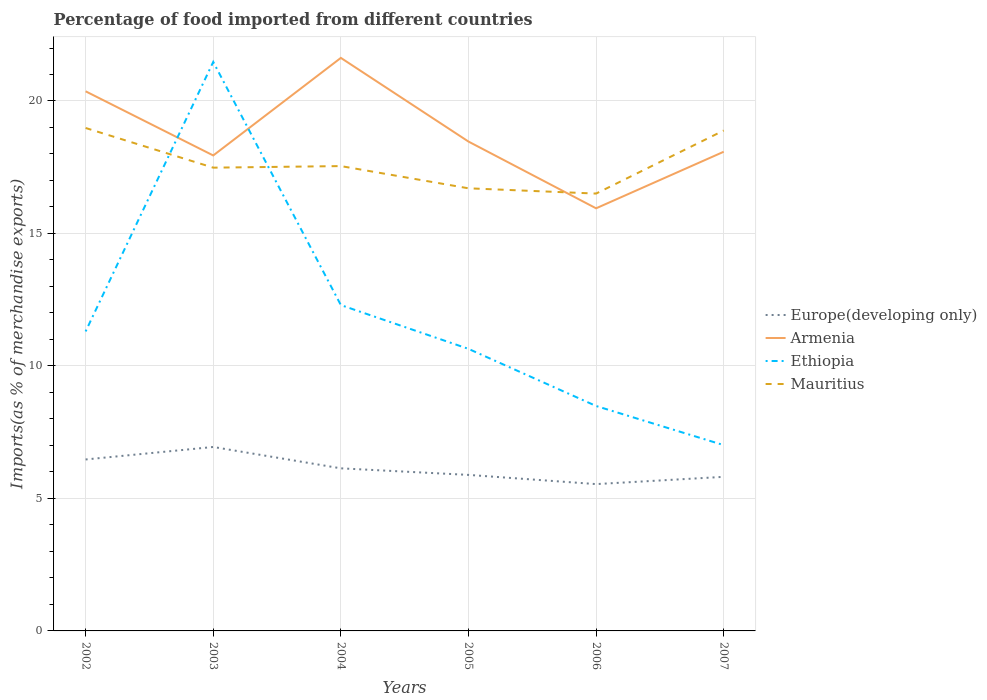Does the line corresponding to Armenia intersect with the line corresponding to Mauritius?
Keep it short and to the point. Yes. Is the number of lines equal to the number of legend labels?
Offer a terse response. Yes. Across all years, what is the maximum percentage of imports to different countries in Europe(developing only)?
Keep it short and to the point. 5.54. In which year was the percentage of imports to different countries in Europe(developing only) maximum?
Give a very brief answer. 2006. What is the total percentage of imports to different countries in Ethiopia in the graph?
Make the answer very short. 3.81. What is the difference between the highest and the second highest percentage of imports to different countries in Armenia?
Ensure brevity in your answer.  5.68. How many lines are there?
Offer a terse response. 4. What is the difference between two consecutive major ticks on the Y-axis?
Ensure brevity in your answer.  5. Are the values on the major ticks of Y-axis written in scientific E-notation?
Provide a short and direct response. No. Does the graph contain grids?
Offer a very short reply. Yes. How many legend labels are there?
Give a very brief answer. 4. How are the legend labels stacked?
Provide a short and direct response. Vertical. What is the title of the graph?
Keep it short and to the point. Percentage of food imported from different countries. What is the label or title of the Y-axis?
Offer a terse response. Imports(as % of merchandise exports). What is the Imports(as % of merchandise exports) in Europe(developing only) in 2002?
Make the answer very short. 6.47. What is the Imports(as % of merchandise exports) of Armenia in 2002?
Provide a short and direct response. 20.37. What is the Imports(as % of merchandise exports) in Ethiopia in 2002?
Keep it short and to the point. 11.3. What is the Imports(as % of merchandise exports) in Mauritius in 2002?
Your answer should be very brief. 18.98. What is the Imports(as % of merchandise exports) of Europe(developing only) in 2003?
Your answer should be compact. 6.94. What is the Imports(as % of merchandise exports) of Armenia in 2003?
Offer a terse response. 17.94. What is the Imports(as % of merchandise exports) in Ethiopia in 2003?
Make the answer very short. 21.47. What is the Imports(as % of merchandise exports) in Mauritius in 2003?
Make the answer very short. 17.48. What is the Imports(as % of merchandise exports) in Europe(developing only) in 2004?
Your answer should be compact. 6.14. What is the Imports(as % of merchandise exports) of Armenia in 2004?
Your response must be concise. 21.63. What is the Imports(as % of merchandise exports) in Ethiopia in 2004?
Provide a short and direct response. 12.3. What is the Imports(as % of merchandise exports) of Mauritius in 2004?
Ensure brevity in your answer.  17.54. What is the Imports(as % of merchandise exports) in Europe(developing only) in 2005?
Offer a terse response. 5.89. What is the Imports(as % of merchandise exports) of Armenia in 2005?
Offer a terse response. 18.47. What is the Imports(as % of merchandise exports) in Ethiopia in 2005?
Provide a succinct answer. 10.64. What is the Imports(as % of merchandise exports) of Mauritius in 2005?
Offer a terse response. 16.7. What is the Imports(as % of merchandise exports) of Europe(developing only) in 2006?
Offer a terse response. 5.54. What is the Imports(as % of merchandise exports) in Armenia in 2006?
Offer a very short reply. 15.95. What is the Imports(as % of merchandise exports) in Ethiopia in 2006?
Your response must be concise. 8.49. What is the Imports(as % of merchandise exports) in Mauritius in 2006?
Provide a succinct answer. 16.51. What is the Imports(as % of merchandise exports) of Europe(developing only) in 2007?
Keep it short and to the point. 5.82. What is the Imports(as % of merchandise exports) in Armenia in 2007?
Make the answer very short. 18.08. What is the Imports(as % of merchandise exports) of Ethiopia in 2007?
Ensure brevity in your answer.  7.01. What is the Imports(as % of merchandise exports) in Mauritius in 2007?
Your response must be concise. 18.89. Across all years, what is the maximum Imports(as % of merchandise exports) of Europe(developing only)?
Your answer should be very brief. 6.94. Across all years, what is the maximum Imports(as % of merchandise exports) of Armenia?
Your response must be concise. 21.63. Across all years, what is the maximum Imports(as % of merchandise exports) in Ethiopia?
Keep it short and to the point. 21.47. Across all years, what is the maximum Imports(as % of merchandise exports) of Mauritius?
Provide a short and direct response. 18.98. Across all years, what is the minimum Imports(as % of merchandise exports) in Europe(developing only)?
Offer a terse response. 5.54. Across all years, what is the minimum Imports(as % of merchandise exports) in Armenia?
Your answer should be compact. 15.95. Across all years, what is the minimum Imports(as % of merchandise exports) of Ethiopia?
Give a very brief answer. 7.01. Across all years, what is the minimum Imports(as % of merchandise exports) in Mauritius?
Give a very brief answer. 16.51. What is the total Imports(as % of merchandise exports) in Europe(developing only) in the graph?
Ensure brevity in your answer.  36.79. What is the total Imports(as % of merchandise exports) in Armenia in the graph?
Provide a short and direct response. 112.44. What is the total Imports(as % of merchandise exports) of Ethiopia in the graph?
Provide a succinct answer. 71.22. What is the total Imports(as % of merchandise exports) in Mauritius in the graph?
Your response must be concise. 106.11. What is the difference between the Imports(as % of merchandise exports) of Europe(developing only) in 2002 and that in 2003?
Offer a terse response. -0.47. What is the difference between the Imports(as % of merchandise exports) of Armenia in 2002 and that in 2003?
Your answer should be very brief. 2.42. What is the difference between the Imports(as % of merchandise exports) in Ethiopia in 2002 and that in 2003?
Keep it short and to the point. -10.17. What is the difference between the Imports(as % of merchandise exports) in Mauritius in 2002 and that in 2003?
Ensure brevity in your answer.  1.5. What is the difference between the Imports(as % of merchandise exports) of Europe(developing only) in 2002 and that in 2004?
Your answer should be compact. 0.33. What is the difference between the Imports(as % of merchandise exports) in Armenia in 2002 and that in 2004?
Provide a short and direct response. -1.26. What is the difference between the Imports(as % of merchandise exports) of Ethiopia in 2002 and that in 2004?
Keep it short and to the point. -0.99. What is the difference between the Imports(as % of merchandise exports) in Mauritius in 2002 and that in 2004?
Give a very brief answer. 1.44. What is the difference between the Imports(as % of merchandise exports) in Europe(developing only) in 2002 and that in 2005?
Ensure brevity in your answer.  0.58. What is the difference between the Imports(as % of merchandise exports) of Armenia in 2002 and that in 2005?
Provide a short and direct response. 1.9. What is the difference between the Imports(as % of merchandise exports) in Ethiopia in 2002 and that in 2005?
Your response must be concise. 0.66. What is the difference between the Imports(as % of merchandise exports) in Mauritius in 2002 and that in 2005?
Your answer should be compact. 2.28. What is the difference between the Imports(as % of merchandise exports) of Europe(developing only) in 2002 and that in 2006?
Your response must be concise. 0.93. What is the difference between the Imports(as % of merchandise exports) in Armenia in 2002 and that in 2006?
Ensure brevity in your answer.  4.42. What is the difference between the Imports(as % of merchandise exports) of Ethiopia in 2002 and that in 2006?
Provide a succinct answer. 2.81. What is the difference between the Imports(as % of merchandise exports) in Mauritius in 2002 and that in 2006?
Offer a very short reply. 2.48. What is the difference between the Imports(as % of merchandise exports) in Europe(developing only) in 2002 and that in 2007?
Offer a very short reply. 0.66. What is the difference between the Imports(as % of merchandise exports) in Armenia in 2002 and that in 2007?
Give a very brief answer. 2.28. What is the difference between the Imports(as % of merchandise exports) in Ethiopia in 2002 and that in 2007?
Provide a short and direct response. 4.29. What is the difference between the Imports(as % of merchandise exports) in Mauritius in 2002 and that in 2007?
Your answer should be very brief. 0.09. What is the difference between the Imports(as % of merchandise exports) in Europe(developing only) in 2003 and that in 2004?
Your answer should be compact. 0.81. What is the difference between the Imports(as % of merchandise exports) in Armenia in 2003 and that in 2004?
Offer a terse response. -3.68. What is the difference between the Imports(as % of merchandise exports) in Ethiopia in 2003 and that in 2004?
Make the answer very short. 9.18. What is the difference between the Imports(as % of merchandise exports) of Mauritius in 2003 and that in 2004?
Keep it short and to the point. -0.06. What is the difference between the Imports(as % of merchandise exports) in Europe(developing only) in 2003 and that in 2005?
Provide a succinct answer. 1.05. What is the difference between the Imports(as % of merchandise exports) in Armenia in 2003 and that in 2005?
Ensure brevity in your answer.  -0.52. What is the difference between the Imports(as % of merchandise exports) of Ethiopia in 2003 and that in 2005?
Your response must be concise. 10.83. What is the difference between the Imports(as % of merchandise exports) of Mauritius in 2003 and that in 2005?
Your answer should be very brief. 0.78. What is the difference between the Imports(as % of merchandise exports) in Europe(developing only) in 2003 and that in 2006?
Your answer should be compact. 1.4. What is the difference between the Imports(as % of merchandise exports) of Armenia in 2003 and that in 2006?
Your answer should be compact. 1.99. What is the difference between the Imports(as % of merchandise exports) in Ethiopia in 2003 and that in 2006?
Keep it short and to the point. 12.99. What is the difference between the Imports(as % of merchandise exports) of Mauritius in 2003 and that in 2006?
Provide a short and direct response. 0.98. What is the difference between the Imports(as % of merchandise exports) of Europe(developing only) in 2003 and that in 2007?
Provide a short and direct response. 1.13. What is the difference between the Imports(as % of merchandise exports) in Armenia in 2003 and that in 2007?
Make the answer very short. -0.14. What is the difference between the Imports(as % of merchandise exports) of Ethiopia in 2003 and that in 2007?
Your response must be concise. 14.46. What is the difference between the Imports(as % of merchandise exports) in Mauritius in 2003 and that in 2007?
Offer a terse response. -1.4. What is the difference between the Imports(as % of merchandise exports) in Europe(developing only) in 2004 and that in 2005?
Your answer should be very brief. 0.25. What is the difference between the Imports(as % of merchandise exports) in Armenia in 2004 and that in 2005?
Provide a short and direct response. 3.16. What is the difference between the Imports(as % of merchandise exports) in Ethiopia in 2004 and that in 2005?
Your answer should be compact. 1.65. What is the difference between the Imports(as % of merchandise exports) in Mauritius in 2004 and that in 2005?
Offer a terse response. 0.84. What is the difference between the Imports(as % of merchandise exports) of Europe(developing only) in 2004 and that in 2006?
Give a very brief answer. 0.6. What is the difference between the Imports(as % of merchandise exports) of Armenia in 2004 and that in 2006?
Give a very brief answer. 5.68. What is the difference between the Imports(as % of merchandise exports) in Ethiopia in 2004 and that in 2006?
Make the answer very short. 3.81. What is the difference between the Imports(as % of merchandise exports) of Mauritius in 2004 and that in 2006?
Make the answer very short. 1.04. What is the difference between the Imports(as % of merchandise exports) in Europe(developing only) in 2004 and that in 2007?
Keep it short and to the point. 0.32. What is the difference between the Imports(as % of merchandise exports) of Armenia in 2004 and that in 2007?
Your answer should be compact. 3.54. What is the difference between the Imports(as % of merchandise exports) of Ethiopia in 2004 and that in 2007?
Your answer should be compact. 5.28. What is the difference between the Imports(as % of merchandise exports) of Mauritius in 2004 and that in 2007?
Offer a very short reply. -1.34. What is the difference between the Imports(as % of merchandise exports) of Europe(developing only) in 2005 and that in 2006?
Keep it short and to the point. 0.35. What is the difference between the Imports(as % of merchandise exports) of Armenia in 2005 and that in 2006?
Your response must be concise. 2.52. What is the difference between the Imports(as % of merchandise exports) in Ethiopia in 2005 and that in 2006?
Provide a succinct answer. 2.16. What is the difference between the Imports(as % of merchandise exports) of Mauritius in 2005 and that in 2006?
Offer a terse response. 0.2. What is the difference between the Imports(as % of merchandise exports) of Europe(developing only) in 2005 and that in 2007?
Make the answer very short. 0.07. What is the difference between the Imports(as % of merchandise exports) in Armenia in 2005 and that in 2007?
Provide a short and direct response. 0.38. What is the difference between the Imports(as % of merchandise exports) in Ethiopia in 2005 and that in 2007?
Keep it short and to the point. 3.63. What is the difference between the Imports(as % of merchandise exports) of Mauritius in 2005 and that in 2007?
Ensure brevity in your answer.  -2.18. What is the difference between the Imports(as % of merchandise exports) of Europe(developing only) in 2006 and that in 2007?
Offer a very short reply. -0.27. What is the difference between the Imports(as % of merchandise exports) of Armenia in 2006 and that in 2007?
Make the answer very short. -2.13. What is the difference between the Imports(as % of merchandise exports) in Ethiopia in 2006 and that in 2007?
Provide a succinct answer. 1.48. What is the difference between the Imports(as % of merchandise exports) of Mauritius in 2006 and that in 2007?
Provide a succinct answer. -2.38. What is the difference between the Imports(as % of merchandise exports) in Europe(developing only) in 2002 and the Imports(as % of merchandise exports) in Armenia in 2003?
Your response must be concise. -11.47. What is the difference between the Imports(as % of merchandise exports) in Europe(developing only) in 2002 and the Imports(as % of merchandise exports) in Ethiopia in 2003?
Your response must be concise. -15. What is the difference between the Imports(as % of merchandise exports) of Europe(developing only) in 2002 and the Imports(as % of merchandise exports) of Mauritius in 2003?
Ensure brevity in your answer.  -11.01. What is the difference between the Imports(as % of merchandise exports) in Armenia in 2002 and the Imports(as % of merchandise exports) in Ethiopia in 2003?
Provide a succinct answer. -1.11. What is the difference between the Imports(as % of merchandise exports) of Armenia in 2002 and the Imports(as % of merchandise exports) of Mauritius in 2003?
Offer a terse response. 2.88. What is the difference between the Imports(as % of merchandise exports) of Ethiopia in 2002 and the Imports(as % of merchandise exports) of Mauritius in 2003?
Your answer should be very brief. -6.18. What is the difference between the Imports(as % of merchandise exports) of Europe(developing only) in 2002 and the Imports(as % of merchandise exports) of Armenia in 2004?
Provide a succinct answer. -15.16. What is the difference between the Imports(as % of merchandise exports) of Europe(developing only) in 2002 and the Imports(as % of merchandise exports) of Ethiopia in 2004?
Provide a succinct answer. -5.83. What is the difference between the Imports(as % of merchandise exports) in Europe(developing only) in 2002 and the Imports(as % of merchandise exports) in Mauritius in 2004?
Your response must be concise. -11.07. What is the difference between the Imports(as % of merchandise exports) in Armenia in 2002 and the Imports(as % of merchandise exports) in Ethiopia in 2004?
Make the answer very short. 8.07. What is the difference between the Imports(as % of merchandise exports) in Armenia in 2002 and the Imports(as % of merchandise exports) in Mauritius in 2004?
Give a very brief answer. 2.82. What is the difference between the Imports(as % of merchandise exports) in Ethiopia in 2002 and the Imports(as % of merchandise exports) in Mauritius in 2004?
Ensure brevity in your answer.  -6.24. What is the difference between the Imports(as % of merchandise exports) of Europe(developing only) in 2002 and the Imports(as % of merchandise exports) of Armenia in 2005?
Your answer should be compact. -12. What is the difference between the Imports(as % of merchandise exports) of Europe(developing only) in 2002 and the Imports(as % of merchandise exports) of Ethiopia in 2005?
Your answer should be compact. -4.17. What is the difference between the Imports(as % of merchandise exports) in Europe(developing only) in 2002 and the Imports(as % of merchandise exports) in Mauritius in 2005?
Your response must be concise. -10.23. What is the difference between the Imports(as % of merchandise exports) in Armenia in 2002 and the Imports(as % of merchandise exports) in Ethiopia in 2005?
Ensure brevity in your answer.  9.72. What is the difference between the Imports(as % of merchandise exports) of Armenia in 2002 and the Imports(as % of merchandise exports) of Mauritius in 2005?
Provide a succinct answer. 3.66. What is the difference between the Imports(as % of merchandise exports) in Ethiopia in 2002 and the Imports(as % of merchandise exports) in Mauritius in 2005?
Make the answer very short. -5.4. What is the difference between the Imports(as % of merchandise exports) of Europe(developing only) in 2002 and the Imports(as % of merchandise exports) of Armenia in 2006?
Your answer should be very brief. -9.48. What is the difference between the Imports(as % of merchandise exports) of Europe(developing only) in 2002 and the Imports(as % of merchandise exports) of Ethiopia in 2006?
Your answer should be compact. -2.02. What is the difference between the Imports(as % of merchandise exports) in Europe(developing only) in 2002 and the Imports(as % of merchandise exports) in Mauritius in 2006?
Provide a short and direct response. -10.04. What is the difference between the Imports(as % of merchandise exports) in Armenia in 2002 and the Imports(as % of merchandise exports) in Ethiopia in 2006?
Your answer should be compact. 11.88. What is the difference between the Imports(as % of merchandise exports) of Armenia in 2002 and the Imports(as % of merchandise exports) of Mauritius in 2006?
Ensure brevity in your answer.  3.86. What is the difference between the Imports(as % of merchandise exports) of Ethiopia in 2002 and the Imports(as % of merchandise exports) of Mauritius in 2006?
Offer a terse response. -5.2. What is the difference between the Imports(as % of merchandise exports) in Europe(developing only) in 2002 and the Imports(as % of merchandise exports) in Armenia in 2007?
Your response must be concise. -11.61. What is the difference between the Imports(as % of merchandise exports) in Europe(developing only) in 2002 and the Imports(as % of merchandise exports) in Ethiopia in 2007?
Keep it short and to the point. -0.54. What is the difference between the Imports(as % of merchandise exports) of Europe(developing only) in 2002 and the Imports(as % of merchandise exports) of Mauritius in 2007?
Your response must be concise. -12.42. What is the difference between the Imports(as % of merchandise exports) of Armenia in 2002 and the Imports(as % of merchandise exports) of Ethiopia in 2007?
Make the answer very short. 13.35. What is the difference between the Imports(as % of merchandise exports) of Armenia in 2002 and the Imports(as % of merchandise exports) of Mauritius in 2007?
Give a very brief answer. 1.48. What is the difference between the Imports(as % of merchandise exports) in Ethiopia in 2002 and the Imports(as % of merchandise exports) in Mauritius in 2007?
Give a very brief answer. -7.58. What is the difference between the Imports(as % of merchandise exports) of Europe(developing only) in 2003 and the Imports(as % of merchandise exports) of Armenia in 2004?
Make the answer very short. -14.68. What is the difference between the Imports(as % of merchandise exports) in Europe(developing only) in 2003 and the Imports(as % of merchandise exports) in Ethiopia in 2004?
Your answer should be compact. -5.36. What is the difference between the Imports(as % of merchandise exports) of Europe(developing only) in 2003 and the Imports(as % of merchandise exports) of Mauritius in 2004?
Give a very brief answer. -10.6. What is the difference between the Imports(as % of merchandise exports) in Armenia in 2003 and the Imports(as % of merchandise exports) in Ethiopia in 2004?
Your answer should be compact. 5.65. What is the difference between the Imports(as % of merchandise exports) in Armenia in 2003 and the Imports(as % of merchandise exports) in Mauritius in 2004?
Keep it short and to the point. 0.4. What is the difference between the Imports(as % of merchandise exports) in Ethiopia in 2003 and the Imports(as % of merchandise exports) in Mauritius in 2004?
Give a very brief answer. 3.93. What is the difference between the Imports(as % of merchandise exports) in Europe(developing only) in 2003 and the Imports(as % of merchandise exports) in Armenia in 2005?
Your answer should be very brief. -11.53. What is the difference between the Imports(as % of merchandise exports) of Europe(developing only) in 2003 and the Imports(as % of merchandise exports) of Ethiopia in 2005?
Provide a short and direct response. -3.7. What is the difference between the Imports(as % of merchandise exports) of Europe(developing only) in 2003 and the Imports(as % of merchandise exports) of Mauritius in 2005?
Keep it short and to the point. -9.76. What is the difference between the Imports(as % of merchandise exports) in Armenia in 2003 and the Imports(as % of merchandise exports) in Ethiopia in 2005?
Give a very brief answer. 7.3. What is the difference between the Imports(as % of merchandise exports) in Armenia in 2003 and the Imports(as % of merchandise exports) in Mauritius in 2005?
Give a very brief answer. 1.24. What is the difference between the Imports(as % of merchandise exports) of Ethiopia in 2003 and the Imports(as % of merchandise exports) of Mauritius in 2005?
Keep it short and to the point. 4.77. What is the difference between the Imports(as % of merchandise exports) in Europe(developing only) in 2003 and the Imports(as % of merchandise exports) in Armenia in 2006?
Offer a very short reply. -9.01. What is the difference between the Imports(as % of merchandise exports) of Europe(developing only) in 2003 and the Imports(as % of merchandise exports) of Ethiopia in 2006?
Give a very brief answer. -1.55. What is the difference between the Imports(as % of merchandise exports) of Europe(developing only) in 2003 and the Imports(as % of merchandise exports) of Mauritius in 2006?
Ensure brevity in your answer.  -9.56. What is the difference between the Imports(as % of merchandise exports) in Armenia in 2003 and the Imports(as % of merchandise exports) in Ethiopia in 2006?
Give a very brief answer. 9.46. What is the difference between the Imports(as % of merchandise exports) in Armenia in 2003 and the Imports(as % of merchandise exports) in Mauritius in 2006?
Your answer should be compact. 1.44. What is the difference between the Imports(as % of merchandise exports) in Ethiopia in 2003 and the Imports(as % of merchandise exports) in Mauritius in 2006?
Offer a terse response. 4.97. What is the difference between the Imports(as % of merchandise exports) of Europe(developing only) in 2003 and the Imports(as % of merchandise exports) of Armenia in 2007?
Keep it short and to the point. -11.14. What is the difference between the Imports(as % of merchandise exports) of Europe(developing only) in 2003 and the Imports(as % of merchandise exports) of Ethiopia in 2007?
Your answer should be compact. -0.07. What is the difference between the Imports(as % of merchandise exports) in Europe(developing only) in 2003 and the Imports(as % of merchandise exports) in Mauritius in 2007?
Your answer should be very brief. -11.94. What is the difference between the Imports(as % of merchandise exports) of Armenia in 2003 and the Imports(as % of merchandise exports) of Ethiopia in 2007?
Make the answer very short. 10.93. What is the difference between the Imports(as % of merchandise exports) of Armenia in 2003 and the Imports(as % of merchandise exports) of Mauritius in 2007?
Offer a terse response. -0.94. What is the difference between the Imports(as % of merchandise exports) of Ethiopia in 2003 and the Imports(as % of merchandise exports) of Mauritius in 2007?
Offer a very short reply. 2.59. What is the difference between the Imports(as % of merchandise exports) of Europe(developing only) in 2004 and the Imports(as % of merchandise exports) of Armenia in 2005?
Provide a short and direct response. -12.33. What is the difference between the Imports(as % of merchandise exports) of Europe(developing only) in 2004 and the Imports(as % of merchandise exports) of Ethiopia in 2005?
Ensure brevity in your answer.  -4.51. What is the difference between the Imports(as % of merchandise exports) in Europe(developing only) in 2004 and the Imports(as % of merchandise exports) in Mauritius in 2005?
Ensure brevity in your answer.  -10.57. What is the difference between the Imports(as % of merchandise exports) of Armenia in 2004 and the Imports(as % of merchandise exports) of Ethiopia in 2005?
Keep it short and to the point. 10.98. What is the difference between the Imports(as % of merchandise exports) of Armenia in 2004 and the Imports(as % of merchandise exports) of Mauritius in 2005?
Ensure brevity in your answer.  4.92. What is the difference between the Imports(as % of merchandise exports) in Ethiopia in 2004 and the Imports(as % of merchandise exports) in Mauritius in 2005?
Provide a succinct answer. -4.41. What is the difference between the Imports(as % of merchandise exports) in Europe(developing only) in 2004 and the Imports(as % of merchandise exports) in Armenia in 2006?
Your response must be concise. -9.81. What is the difference between the Imports(as % of merchandise exports) in Europe(developing only) in 2004 and the Imports(as % of merchandise exports) in Ethiopia in 2006?
Keep it short and to the point. -2.35. What is the difference between the Imports(as % of merchandise exports) of Europe(developing only) in 2004 and the Imports(as % of merchandise exports) of Mauritius in 2006?
Make the answer very short. -10.37. What is the difference between the Imports(as % of merchandise exports) in Armenia in 2004 and the Imports(as % of merchandise exports) in Ethiopia in 2006?
Offer a very short reply. 13.14. What is the difference between the Imports(as % of merchandise exports) in Armenia in 2004 and the Imports(as % of merchandise exports) in Mauritius in 2006?
Ensure brevity in your answer.  5.12. What is the difference between the Imports(as % of merchandise exports) in Ethiopia in 2004 and the Imports(as % of merchandise exports) in Mauritius in 2006?
Your answer should be compact. -4.21. What is the difference between the Imports(as % of merchandise exports) in Europe(developing only) in 2004 and the Imports(as % of merchandise exports) in Armenia in 2007?
Keep it short and to the point. -11.95. What is the difference between the Imports(as % of merchandise exports) in Europe(developing only) in 2004 and the Imports(as % of merchandise exports) in Ethiopia in 2007?
Your answer should be compact. -0.88. What is the difference between the Imports(as % of merchandise exports) of Europe(developing only) in 2004 and the Imports(as % of merchandise exports) of Mauritius in 2007?
Give a very brief answer. -12.75. What is the difference between the Imports(as % of merchandise exports) in Armenia in 2004 and the Imports(as % of merchandise exports) in Ethiopia in 2007?
Offer a very short reply. 14.61. What is the difference between the Imports(as % of merchandise exports) in Armenia in 2004 and the Imports(as % of merchandise exports) in Mauritius in 2007?
Ensure brevity in your answer.  2.74. What is the difference between the Imports(as % of merchandise exports) in Ethiopia in 2004 and the Imports(as % of merchandise exports) in Mauritius in 2007?
Offer a very short reply. -6.59. What is the difference between the Imports(as % of merchandise exports) of Europe(developing only) in 2005 and the Imports(as % of merchandise exports) of Armenia in 2006?
Make the answer very short. -10.06. What is the difference between the Imports(as % of merchandise exports) of Europe(developing only) in 2005 and the Imports(as % of merchandise exports) of Ethiopia in 2006?
Keep it short and to the point. -2.6. What is the difference between the Imports(as % of merchandise exports) of Europe(developing only) in 2005 and the Imports(as % of merchandise exports) of Mauritius in 2006?
Make the answer very short. -10.62. What is the difference between the Imports(as % of merchandise exports) in Armenia in 2005 and the Imports(as % of merchandise exports) in Ethiopia in 2006?
Your response must be concise. 9.98. What is the difference between the Imports(as % of merchandise exports) in Armenia in 2005 and the Imports(as % of merchandise exports) in Mauritius in 2006?
Give a very brief answer. 1.96. What is the difference between the Imports(as % of merchandise exports) in Ethiopia in 2005 and the Imports(as % of merchandise exports) in Mauritius in 2006?
Keep it short and to the point. -5.86. What is the difference between the Imports(as % of merchandise exports) in Europe(developing only) in 2005 and the Imports(as % of merchandise exports) in Armenia in 2007?
Ensure brevity in your answer.  -12.2. What is the difference between the Imports(as % of merchandise exports) in Europe(developing only) in 2005 and the Imports(as % of merchandise exports) in Ethiopia in 2007?
Ensure brevity in your answer.  -1.12. What is the difference between the Imports(as % of merchandise exports) in Europe(developing only) in 2005 and the Imports(as % of merchandise exports) in Mauritius in 2007?
Provide a succinct answer. -13. What is the difference between the Imports(as % of merchandise exports) in Armenia in 2005 and the Imports(as % of merchandise exports) in Ethiopia in 2007?
Your answer should be compact. 11.46. What is the difference between the Imports(as % of merchandise exports) of Armenia in 2005 and the Imports(as % of merchandise exports) of Mauritius in 2007?
Make the answer very short. -0.42. What is the difference between the Imports(as % of merchandise exports) of Ethiopia in 2005 and the Imports(as % of merchandise exports) of Mauritius in 2007?
Your answer should be compact. -8.24. What is the difference between the Imports(as % of merchandise exports) in Europe(developing only) in 2006 and the Imports(as % of merchandise exports) in Armenia in 2007?
Offer a terse response. -12.54. What is the difference between the Imports(as % of merchandise exports) in Europe(developing only) in 2006 and the Imports(as % of merchandise exports) in Ethiopia in 2007?
Offer a terse response. -1.47. What is the difference between the Imports(as % of merchandise exports) in Europe(developing only) in 2006 and the Imports(as % of merchandise exports) in Mauritius in 2007?
Your answer should be very brief. -13.35. What is the difference between the Imports(as % of merchandise exports) of Armenia in 2006 and the Imports(as % of merchandise exports) of Ethiopia in 2007?
Ensure brevity in your answer.  8.94. What is the difference between the Imports(as % of merchandise exports) in Armenia in 2006 and the Imports(as % of merchandise exports) in Mauritius in 2007?
Your response must be concise. -2.94. What is the difference between the Imports(as % of merchandise exports) in Ethiopia in 2006 and the Imports(as % of merchandise exports) in Mauritius in 2007?
Your answer should be compact. -10.4. What is the average Imports(as % of merchandise exports) in Europe(developing only) per year?
Provide a short and direct response. 6.13. What is the average Imports(as % of merchandise exports) of Armenia per year?
Ensure brevity in your answer.  18.74. What is the average Imports(as % of merchandise exports) in Ethiopia per year?
Your answer should be very brief. 11.87. What is the average Imports(as % of merchandise exports) of Mauritius per year?
Offer a terse response. 17.68. In the year 2002, what is the difference between the Imports(as % of merchandise exports) of Europe(developing only) and Imports(as % of merchandise exports) of Armenia?
Your answer should be compact. -13.89. In the year 2002, what is the difference between the Imports(as % of merchandise exports) in Europe(developing only) and Imports(as % of merchandise exports) in Ethiopia?
Your response must be concise. -4.83. In the year 2002, what is the difference between the Imports(as % of merchandise exports) of Europe(developing only) and Imports(as % of merchandise exports) of Mauritius?
Offer a terse response. -12.51. In the year 2002, what is the difference between the Imports(as % of merchandise exports) of Armenia and Imports(as % of merchandise exports) of Ethiopia?
Your answer should be very brief. 9.06. In the year 2002, what is the difference between the Imports(as % of merchandise exports) in Armenia and Imports(as % of merchandise exports) in Mauritius?
Your response must be concise. 1.38. In the year 2002, what is the difference between the Imports(as % of merchandise exports) in Ethiopia and Imports(as % of merchandise exports) in Mauritius?
Offer a very short reply. -7.68. In the year 2003, what is the difference between the Imports(as % of merchandise exports) in Europe(developing only) and Imports(as % of merchandise exports) in Armenia?
Provide a short and direct response. -11. In the year 2003, what is the difference between the Imports(as % of merchandise exports) of Europe(developing only) and Imports(as % of merchandise exports) of Ethiopia?
Your answer should be very brief. -14.53. In the year 2003, what is the difference between the Imports(as % of merchandise exports) of Europe(developing only) and Imports(as % of merchandise exports) of Mauritius?
Your answer should be compact. -10.54. In the year 2003, what is the difference between the Imports(as % of merchandise exports) of Armenia and Imports(as % of merchandise exports) of Ethiopia?
Your answer should be very brief. -3.53. In the year 2003, what is the difference between the Imports(as % of merchandise exports) of Armenia and Imports(as % of merchandise exports) of Mauritius?
Make the answer very short. 0.46. In the year 2003, what is the difference between the Imports(as % of merchandise exports) in Ethiopia and Imports(as % of merchandise exports) in Mauritius?
Give a very brief answer. 3.99. In the year 2004, what is the difference between the Imports(as % of merchandise exports) in Europe(developing only) and Imports(as % of merchandise exports) in Armenia?
Your response must be concise. -15.49. In the year 2004, what is the difference between the Imports(as % of merchandise exports) in Europe(developing only) and Imports(as % of merchandise exports) in Ethiopia?
Your answer should be very brief. -6.16. In the year 2004, what is the difference between the Imports(as % of merchandise exports) of Europe(developing only) and Imports(as % of merchandise exports) of Mauritius?
Offer a terse response. -11.41. In the year 2004, what is the difference between the Imports(as % of merchandise exports) in Armenia and Imports(as % of merchandise exports) in Ethiopia?
Keep it short and to the point. 9.33. In the year 2004, what is the difference between the Imports(as % of merchandise exports) of Armenia and Imports(as % of merchandise exports) of Mauritius?
Provide a succinct answer. 4.08. In the year 2004, what is the difference between the Imports(as % of merchandise exports) in Ethiopia and Imports(as % of merchandise exports) in Mauritius?
Provide a succinct answer. -5.25. In the year 2005, what is the difference between the Imports(as % of merchandise exports) of Europe(developing only) and Imports(as % of merchandise exports) of Armenia?
Ensure brevity in your answer.  -12.58. In the year 2005, what is the difference between the Imports(as % of merchandise exports) of Europe(developing only) and Imports(as % of merchandise exports) of Ethiopia?
Give a very brief answer. -4.76. In the year 2005, what is the difference between the Imports(as % of merchandise exports) in Europe(developing only) and Imports(as % of merchandise exports) in Mauritius?
Ensure brevity in your answer.  -10.82. In the year 2005, what is the difference between the Imports(as % of merchandise exports) of Armenia and Imports(as % of merchandise exports) of Ethiopia?
Your answer should be very brief. 7.82. In the year 2005, what is the difference between the Imports(as % of merchandise exports) in Armenia and Imports(as % of merchandise exports) in Mauritius?
Offer a very short reply. 1.76. In the year 2005, what is the difference between the Imports(as % of merchandise exports) of Ethiopia and Imports(as % of merchandise exports) of Mauritius?
Your response must be concise. -6.06. In the year 2006, what is the difference between the Imports(as % of merchandise exports) in Europe(developing only) and Imports(as % of merchandise exports) in Armenia?
Ensure brevity in your answer.  -10.41. In the year 2006, what is the difference between the Imports(as % of merchandise exports) of Europe(developing only) and Imports(as % of merchandise exports) of Ethiopia?
Your answer should be compact. -2.95. In the year 2006, what is the difference between the Imports(as % of merchandise exports) in Europe(developing only) and Imports(as % of merchandise exports) in Mauritius?
Provide a short and direct response. -10.96. In the year 2006, what is the difference between the Imports(as % of merchandise exports) in Armenia and Imports(as % of merchandise exports) in Ethiopia?
Your answer should be very brief. 7.46. In the year 2006, what is the difference between the Imports(as % of merchandise exports) of Armenia and Imports(as % of merchandise exports) of Mauritius?
Provide a succinct answer. -0.56. In the year 2006, what is the difference between the Imports(as % of merchandise exports) of Ethiopia and Imports(as % of merchandise exports) of Mauritius?
Your answer should be very brief. -8.02. In the year 2007, what is the difference between the Imports(as % of merchandise exports) in Europe(developing only) and Imports(as % of merchandise exports) in Armenia?
Keep it short and to the point. -12.27. In the year 2007, what is the difference between the Imports(as % of merchandise exports) in Europe(developing only) and Imports(as % of merchandise exports) in Ethiopia?
Give a very brief answer. -1.2. In the year 2007, what is the difference between the Imports(as % of merchandise exports) in Europe(developing only) and Imports(as % of merchandise exports) in Mauritius?
Your answer should be compact. -13.07. In the year 2007, what is the difference between the Imports(as % of merchandise exports) of Armenia and Imports(as % of merchandise exports) of Ethiopia?
Your answer should be compact. 11.07. In the year 2007, what is the difference between the Imports(as % of merchandise exports) in Armenia and Imports(as % of merchandise exports) in Mauritius?
Make the answer very short. -0.8. In the year 2007, what is the difference between the Imports(as % of merchandise exports) in Ethiopia and Imports(as % of merchandise exports) in Mauritius?
Give a very brief answer. -11.87. What is the ratio of the Imports(as % of merchandise exports) of Europe(developing only) in 2002 to that in 2003?
Offer a very short reply. 0.93. What is the ratio of the Imports(as % of merchandise exports) of Armenia in 2002 to that in 2003?
Your answer should be very brief. 1.13. What is the ratio of the Imports(as % of merchandise exports) of Ethiopia in 2002 to that in 2003?
Your answer should be very brief. 0.53. What is the ratio of the Imports(as % of merchandise exports) of Mauritius in 2002 to that in 2003?
Your response must be concise. 1.09. What is the ratio of the Imports(as % of merchandise exports) of Europe(developing only) in 2002 to that in 2004?
Make the answer very short. 1.05. What is the ratio of the Imports(as % of merchandise exports) of Armenia in 2002 to that in 2004?
Make the answer very short. 0.94. What is the ratio of the Imports(as % of merchandise exports) in Ethiopia in 2002 to that in 2004?
Provide a succinct answer. 0.92. What is the ratio of the Imports(as % of merchandise exports) of Mauritius in 2002 to that in 2004?
Provide a short and direct response. 1.08. What is the ratio of the Imports(as % of merchandise exports) of Europe(developing only) in 2002 to that in 2005?
Offer a terse response. 1.1. What is the ratio of the Imports(as % of merchandise exports) of Armenia in 2002 to that in 2005?
Offer a very short reply. 1.1. What is the ratio of the Imports(as % of merchandise exports) in Ethiopia in 2002 to that in 2005?
Your response must be concise. 1.06. What is the ratio of the Imports(as % of merchandise exports) of Mauritius in 2002 to that in 2005?
Provide a short and direct response. 1.14. What is the ratio of the Imports(as % of merchandise exports) of Europe(developing only) in 2002 to that in 2006?
Offer a terse response. 1.17. What is the ratio of the Imports(as % of merchandise exports) of Armenia in 2002 to that in 2006?
Ensure brevity in your answer.  1.28. What is the ratio of the Imports(as % of merchandise exports) in Ethiopia in 2002 to that in 2006?
Your answer should be compact. 1.33. What is the ratio of the Imports(as % of merchandise exports) in Mauritius in 2002 to that in 2006?
Keep it short and to the point. 1.15. What is the ratio of the Imports(as % of merchandise exports) in Europe(developing only) in 2002 to that in 2007?
Your answer should be very brief. 1.11. What is the ratio of the Imports(as % of merchandise exports) of Armenia in 2002 to that in 2007?
Give a very brief answer. 1.13. What is the ratio of the Imports(as % of merchandise exports) in Ethiopia in 2002 to that in 2007?
Provide a short and direct response. 1.61. What is the ratio of the Imports(as % of merchandise exports) in Mauritius in 2002 to that in 2007?
Keep it short and to the point. 1. What is the ratio of the Imports(as % of merchandise exports) of Europe(developing only) in 2003 to that in 2004?
Ensure brevity in your answer.  1.13. What is the ratio of the Imports(as % of merchandise exports) in Armenia in 2003 to that in 2004?
Ensure brevity in your answer.  0.83. What is the ratio of the Imports(as % of merchandise exports) of Ethiopia in 2003 to that in 2004?
Your response must be concise. 1.75. What is the ratio of the Imports(as % of merchandise exports) of Europe(developing only) in 2003 to that in 2005?
Your response must be concise. 1.18. What is the ratio of the Imports(as % of merchandise exports) in Armenia in 2003 to that in 2005?
Provide a short and direct response. 0.97. What is the ratio of the Imports(as % of merchandise exports) in Ethiopia in 2003 to that in 2005?
Ensure brevity in your answer.  2.02. What is the ratio of the Imports(as % of merchandise exports) in Mauritius in 2003 to that in 2005?
Provide a succinct answer. 1.05. What is the ratio of the Imports(as % of merchandise exports) of Europe(developing only) in 2003 to that in 2006?
Make the answer very short. 1.25. What is the ratio of the Imports(as % of merchandise exports) of Armenia in 2003 to that in 2006?
Give a very brief answer. 1.13. What is the ratio of the Imports(as % of merchandise exports) of Ethiopia in 2003 to that in 2006?
Provide a short and direct response. 2.53. What is the ratio of the Imports(as % of merchandise exports) in Mauritius in 2003 to that in 2006?
Make the answer very short. 1.06. What is the ratio of the Imports(as % of merchandise exports) of Europe(developing only) in 2003 to that in 2007?
Your answer should be very brief. 1.19. What is the ratio of the Imports(as % of merchandise exports) in Armenia in 2003 to that in 2007?
Your answer should be compact. 0.99. What is the ratio of the Imports(as % of merchandise exports) of Ethiopia in 2003 to that in 2007?
Ensure brevity in your answer.  3.06. What is the ratio of the Imports(as % of merchandise exports) of Mauritius in 2003 to that in 2007?
Keep it short and to the point. 0.93. What is the ratio of the Imports(as % of merchandise exports) of Europe(developing only) in 2004 to that in 2005?
Keep it short and to the point. 1.04. What is the ratio of the Imports(as % of merchandise exports) in Armenia in 2004 to that in 2005?
Provide a short and direct response. 1.17. What is the ratio of the Imports(as % of merchandise exports) of Ethiopia in 2004 to that in 2005?
Give a very brief answer. 1.16. What is the ratio of the Imports(as % of merchandise exports) of Mauritius in 2004 to that in 2005?
Your answer should be very brief. 1.05. What is the ratio of the Imports(as % of merchandise exports) in Europe(developing only) in 2004 to that in 2006?
Your response must be concise. 1.11. What is the ratio of the Imports(as % of merchandise exports) of Armenia in 2004 to that in 2006?
Provide a succinct answer. 1.36. What is the ratio of the Imports(as % of merchandise exports) in Ethiopia in 2004 to that in 2006?
Provide a succinct answer. 1.45. What is the ratio of the Imports(as % of merchandise exports) of Mauritius in 2004 to that in 2006?
Ensure brevity in your answer.  1.06. What is the ratio of the Imports(as % of merchandise exports) of Europe(developing only) in 2004 to that in 2007?
Keep it short and to the point. 1.06. What is the ratio of the Imports(as % of merchandise exports) in Armenia in 2004 to that in 2007?
Make the answer very short. 1.2. What is the ratio of the Imports(as % of merchandise exports) of Ethiopia in 2004 to that in 2007?
Your response must be concise. 1.75. What is the ratio of the Imports(as % of merchandise exports) of Mauritius in 2004 to that in 2007?
Make the answer very short. 0.93. What is the ratio of the Imports(as % of merchandise exports) of Europe(developing only) in 2005 to that in 2006?
Provide a succinct answer. 1.06. What is the ratio of the Imports(as % of merchandise exports) in Armenia in 2005 to that in 2006?
Make the answer very short. 1.16. What is the ratio of the Imports(as % of merchandise exports) of Ethiopia in 2005 to that in 2006?
Your answer should be very brief. 1.25. What is the ratio of the Imports(as % of merchandise exports) in Mauritius in 2005 to that in 2006?
Provide a short and direct response. 1.01. What is the ratio of the Imports(as % of merchandise exports) in Europe(developing only) in 2005 to that in 2007?
Your response must be concise. 1.01. What is the ratio of the Imports(as % of merchandise exports) in Armenia in 2005 to that in 2007?
Offer a very short reply. 1.02. What is the ratio of the Imports(as % of merchandise exports) in Ethiopia in 2005 to that in 2007?
Ensure brevity in your answer.  1.52. What is the ratio of the Imports(as % of merchandise exports) of Mauritius in 2005 to that in 2007?
Provide a short and direct response. 0.88. What is the ratio of the Imports(as % of merchandise exports) of Europe(developing only) in 2006 to that in 2007?
Your response must be concise. 0.95. What is the ratio of the Imports(as % of merchandise exports) in Armenia in 2006 to that in 2007?
Give a very brief answer. 0.88. What is the ratio of the Imports(as % of merchandise exports) in Ethiopia in 2006 to that in 2007?
Offer a terse response. 1.21. What is the ratio of the Imports(as % of merchandise exports) in Mauritius in 2006 to that in 2007?
Offer a very short reply. 0.87. What is the difference between the highest and the second highest Imports(as % of merchandise exports) in Europe(developing only)?
Keep it short and to the point. 0.47. What is the difference between the highest and the second highest Imports(as % of merchandise exports) in Armenia?
Offer a terse response. 1.26. What is the difference between the highest and the second highest Imports(as % of merchandise exports) of Ethiopia?
Provide a short and direct response. 9.18. What is the difference between the highest and the second highest Imports(as % of merchandise exports) of Mauritius?
Ensure brevity in your answer.  0.09. What is the difference between the highest and the lowest Imports(as % of merchandise exports) of Europe(developing only)?
Make the answer very short. 1.4. What is the difference between the highest and the lowest Imports(as % of merchandise exports) of Armenia?
Make the answer very short. 5.68. What is the difference between the highest and the lowest Imports(as % of merchandise exports) of Ethiopia?
Your answer should be very brief. 14.46. What is the difference between the highest and the lowest Imports(as % of merchandise exports) of Mauritius?
Make the answer very short. 2.48. 